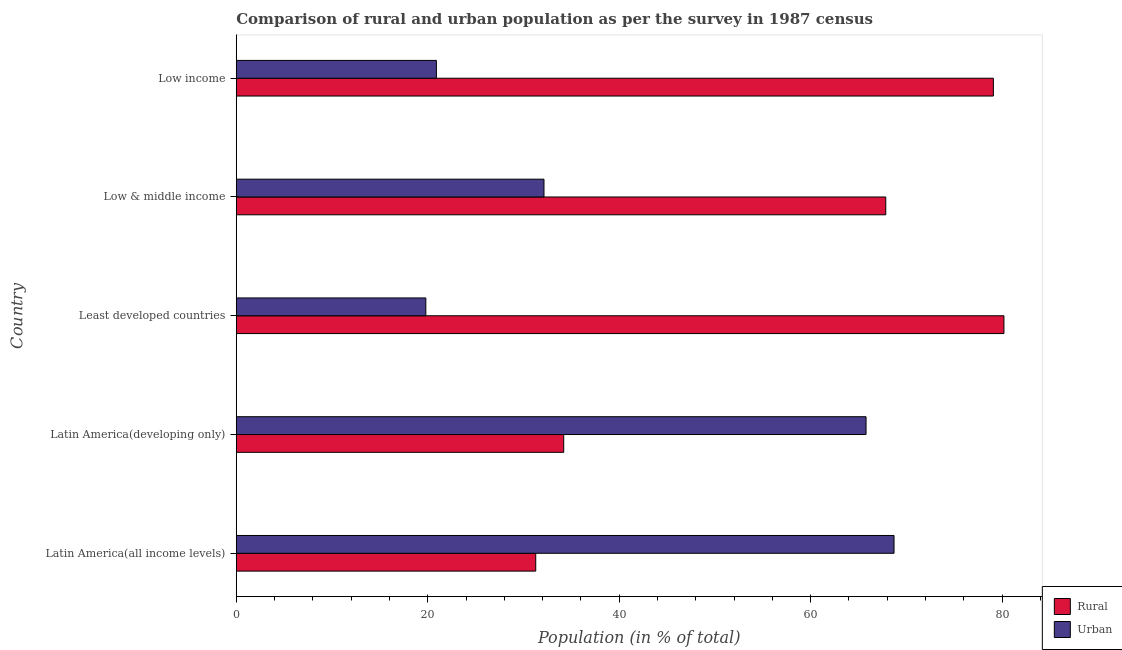How many different coloured bars are there?
Your answer should be compact. 2. How many groups of bars are there?
Provide a succinct answer. 5. Are the number of bars per tick equal to the number of legend labels?
Your answer should be compact. Yes. Are the number of bars on each tick of the Y-axis equal?
Your answer should be very brief. Yes. How many bars are there on the 5th tick from the top?
Your response must be concise. 2. How many bars are there on the 5th tick from the bottom?
Keep it short and to the point. 2. What is the rural population in Least developed countries?
Provide a short and direct response. 80.2. Across all countries, what is the maximum urban population?
Your response must be concise. 68.72. Across all countries, what is the minimum urban population?
Provide a succinct answer. 19.8. In which country was the rural population maximum?
Your answer should be compact. Least developed countries. In which country was the urban population minimum?
Give a very brief answer. Least developed countries. What is the total urban population in the graph?
Make the answer very short. 207.36. What is the difference between the rural population in Latin America(developing only) and that in Low & middle income?
Provide a short and direct response. -33.64. What is the difference between the urban population in Least developed countries and the rural population in Latin America(all income levels)?
Provide a short and direct response. -11.48. What is the average urban population per country?
Make the answer very short. 41.47. What is the difference between the urban population and rural population in Low & middle income?
Give a very brief answer. -35.7. In how many countries, is the rural population greater than 52 %?
Provide a succinct answer. 3. What is the ratio of the urban population in Latin America(all income levels) to that in Latin America(developing only)?
Offer a terse response. 1.04. Is the rural population in Latin America(all income levels) less than that in Least developed countries?
Your answer should be very brief. Yes. What is the difference between the highest and the second highest urban population?
Give a very brief answer. 2.92. What is the difference between the highest and the lowest rural population?
Give a very brief answer. 48.91. Is the sum of the rural population in Latin America(all income levels) and Least developed countries greater than the maximum urban population across all countries?
Offer a terse response. Yes. What does the 2nd bar from the top in Latin America(developing only) represents?
Provide a short and direct response. Rural. What does the 1st bar from the bottom in Low income represents?
Your answer should be compact. Rural. How many bars are there?
Provide a short and direct response. 10. Are all the bars in the graph horizontal?
Your answer should be very brief. Yes. What is the difference between two consecutive major ticks on the X-axis?
Your response must be concise. 20. Does the graph contain any zero values?
Keep it short and to the point. No. How many legend labels are there?
Provide a short and direct response. 2. What is the title of the graph?
Offer a terse response. Comparison of rural and urban population as per the survey in 1987 census. Does "Highest 10% of population" appear as one of the legend labels in the graph?
Offer a terse response. No. What is the label or title of the X-axis?
Offer a very short reply. Population (in % of total). What is the Population (in % of total) in Rural in Latin America(all income levels)?
Your answer should be very brief. 31.28. What is the Population (in % of total) of Urban in Latin America(all income levels)?
Ensure brevity in your answer.  68.72. What is the Population (in % of total) in Rural in Latin America(developing only)?
Keep it short and to the point. 34.21. What is the Population (in % of total) in Urban in Latin America(developing only)?
Make the answer very short. 65.79. What is the Population (in % of total) of Rural in Least developed countries?
Provide a succinct answer. 80.2. What is the Population (in % of total) of Urban in Least developed countries?
Give a very brief answer. 19.8. What is the Population (in % of total) of Rural in Low & middle income?
Provide a short and direct response. 67.85. What is the Population (in % of total) in Urban in Low & middle income?
Keep it short and to the point. 32.15. What is the Population (in % of total) of Rural in Low income?
Ensure brevity in your answer.  79.09. What is the Population (in % of total) of Urban in Low income?
Give a very brief answer. 20.91. Across all countries, what is the maximum Population (in % of total) of Rural?
Provide a short and direct response. 80.2. Across all countries, what is the maximum Population (in % of total) in Urban?
Your answer should be very brief. 68.72. Across all countries, what is the minimum Population (in % of total) of Rural?
Offer a terse response. 31.28. Across all countries, what is the minimum Population (in % of total) of Urban?
Offer a very short reply. 19.8. What is the total Population (in % of total) in Rural in the graph?
Offer a very short reply. 292.64. What is the total Population (in % of total) of Urban in the graph?
Ensure brevity in your answer.  207.36. What is the difference between the Population (in % of total) in Rural in Latin America(all income levels) and that in Latin America(developing only)?
Give a very brief answer. -2.92. What is the difference between the Population (in % of total) of Urban in Latin America(all income levels) and that in Latin America(developing only)?
Your answer should be compact. 2.92. What is the difference between the Population (in % of total) in Rural in Latin America(all income levels) and that in Least developed countries?
Your response must be concise. -48.91. What is the difference between the Population (in % of total) in Urban in Latin America(all income levels) and that in Least developed countries?
Provide a succinct answer. 48.91. What is the difference between the Population (in % of total) in Rural in Latin America(all income levels) and that in Low & middle income?
Your answer should be compact. -36.57. What is the difference between the Population (in % of total) in Urban in Latin America(all income levels) and that in Low & middle income?
Offer a very short reply. 36.57. What is the difference between the Population (in % of total) of Rural in Latin America(all income levels) and that in Low income?
Your answer should be very brief. -47.81. What is the difference between the Population (in % of total) of Urban in Latin America(all income levels) and that in Low income?
Provide a short and direct response. 47.81. What is the difference between the Population (in % of total) of Rural in Latin America(developing only) and that in Least developed countries?
Offer a very short reply. -45.99. What is the difference between the Population (in % of total) of Urban in Latin America(developing only) and that in Least developed countries?
Provide a succinct answer. 45.99. What is the difference between the Population (in % of total) in Rural in Latin America(developing only) and that in Low & middle income?
Your response must be concise. -33.64. What is the difference between the Population (in % of total) of Urban in Latin America(developing only) and that in Low & middle income?
Your answer should be compact. 33.64. What is the difference between the Population (in % of total) in Rural in Latin America(developing only) and that in Low income?
Your answer should be very brief. -44.88. What is the difference between the Population (in % of total) in Urban in Latin America(developing only) and that in Low income?
Give a very brief answer. 44.88. What is the difference between the Population (in % of total) in Rural in Least developed countries and that in Low & middle income?
Provide a short and direct response. 12.34. What is the difference between the Population (in % of total) of Urban in Least developed countries and that in Low & middle income?
Provide a short and direct response. -12.34. What is the difference between the Population (in % of total) of Rural in Least developed countries and that in Low income?
Give a very brief answer. 1.1. What is the difference between the Population (in % of total) of Urban in Least developed countries and that in Low income?
Offer a very short reply. -1.1. What is the difference between the Population (in % of total) of Rural in Low & middle income and that in Low income?
Offer a very short reply. -11.24. What is the difference between the Population (in % of total) of Urban in Low & middle income and that in Low income?
Offer a terse response. 11.24. What is the difference between the Population (in % of total) in Rural in Latin America(all income levels) and the Population (in % of total) in Urban in Latin America(developing only)?
Provide a succinct answer. -34.51. What is the difference between the Population (in % of total) in Rural in Latin America(all income levels) and the Population (in % of total) in Urban in Least developed countries?
Your response must be concise. 11.48. What is the difference between the Population (in % of total) of Rural in Latin America(all income levels) and the Population (in % of total) of Urban in Low & middle income?
Provide a succinct answer. -0.86. What is the difference between the Population (in % of total) in Rural in Latin America(all income levels) and the Population (in % of total) in Urban in Low income?
Your response must be concise. 10.38. What is the difference between the Population (in % of total) in Rural in Latin America(developing only) and the Population (in % of total) in Urban in Least developed countries?
Keep it short and to the point. 14.4. What is the difference between the Population (in % of total) of Rural in Latin America(developing only) and the Population (in % of total) of Urban in Low & middle income?
Provide a succinct answer. 2.06. What is the difference between the Population (in % of total) in Rural in Latin America(developing only) and the Population (in % of total) in Urban in Low income?
Offer a very short reply. 13.3. What is the difference between the Population (in % of total) of Rural in Least developed countries and the Population (in % of total) of Urban in Low & middle income?
Your answer should be compact. 48.05. What is the difference between the Population (in % of total) of Rural in Least developed countries and the Population (in % of total) of Urban in Low income?
Ensure brevity in your answer.  59.29. What is the difference between the Population (in % of total) of Rural in Low & middle income and the Population (in % of total) of Urban in Low income?
Offer a very short reply. 46.95. What is the average Population (in % of total) in Rural per country?
Provide a succinct answer. 58.53. What is the average Population (in % of total) of Urban per country?
Give a very brief answer. 41.47. What is the difference between the Population (in % of total) in Rural and Population (in % of total) in Urban in Latin America(all income levels)?
Offer a terse response. -37.43. What is the difference between the Population (in % of total) in Rural and Population (in % of total) in Urban in Latin America(developing only)?
Offer a terse response. -31.58. What is the difference between the Population (in % of total) of Rural and Population (in % of total) of Urban in Least developed countries?
Offer a very short reply. 60.39. What is the difference between the Population (in % of total) of Rural and Population (in % of total) of Urban in Low & middle income?
Ensure brevity in your answer.  35.7. What is the difference between the Population (in % of total) in Rural and Population (in % of total) in Urban in Low income?
Ensure brevity in your answer.  58.19. What is the ratio of the Population (in % of total) in Rural in Latin America(all income levels) to that in Latin America(developing only)?
Your answer should be very brief. 0.91. What is the ratio of the Population (in % of total) in Urban in Latin America(all income levels) to that in Latin America(developing only)?
Provide a succinct answer. 1.04. What is the ratio of the Population (in % of total) of Rural in Latin America(all income levels) to that in Least developed countries?
Your answer should be very brief. 0.39. What is the ratio of the Population (in % of total) of Urban in Latin America(all income levels) to that in Least developed countries?
Offer a terse response. 3.47. What is the ratio of the Population (in % of total) in Rural in Latin America(all income levels) to that in Low & middle income?
Provide a short and direct response. 0.46. What is the ratio of the Population (in % of total) of Urban in Latin America(all income levels) to that in Low & middle income?
Give a very brief answer. 2.14. What is the ratio of the Population (in % of total) of Rural in Latin America(all income levels) to that in Low income?
Offer a terse response. 0.4. What is the ratio of the Population (in % of total) of Urban in Latin America(all income levels) to that in Low income?
Offer a very short reply. 3.29. What is the ratio of the Population (in % of total) in Rural in Latin America(developing only) to that in Least developed countries?
Provide a succinct answer. 0.43. What is the ratio of the Population (in % of total) of Urban in Latin America(developing only) to that in Least developed countries?
Provide a succinct answer. 3.32. What is the ratio of the Population (in % of total) in Rural in Latin America(developing only) to that in Low & middle income?
Your answer should be compact. 0.5. What is the ratio of the Population (in % of total) in Urban in Latin America(developing only) to that in Low & middle income?
Make the answer very short. 2.05. What is the ratio of the Population (in % of total) in Rural in Latin America(developing only) to that in Low income?
Give a very brief answer. 0.43. What is the ratio of the Population (in % of total) in Urban in Latin America(developing only) to that in Low income?
Offer a terse response. 3.15. What is the ratio of the Population (in % of total) in Rural in Least developed countries to that in Low & middle income?
Ensure brevity in your answer.  1.18. What is the ratio of the Population (in % of total) in Urban in Least developed countries to that in Low & middle income?
Offer a very short reply. 0.62. What is the ratio of the Population (in % of total) of Rural in Least developed countries to that in Low income?
Provide a short and direct response. 1.01. What is the ratio of the Population (in % of total) of Urban in Least developed countries to that in Low income?
Keep it short and to the point. 0.95. What is the ratio of the Population (in % of total) of Rural in Low & middle income to that in Low income?
Provide a short and direct response. 0.86. What is the ratio of the Population (in % of total) of Urban in Low & middle income to that in Low income?
Offer a terse response. 1.54. What is the difference between the highest and the second highest Population (in % of total) of Rural?
Your answer should be very brief. 1.1. What is the difference between the highest and the second highest Population (in % of total) in Urban?
Ensure brevity in your answer.  2.92. What is the difference between the highest and the lowest Population (in % of total) of Rural?
Your answer should be very brief. 48.91. What is the difference between the highest and the lowest Population (in % of total) of Urban?
Your response must be concise. 48.91. 